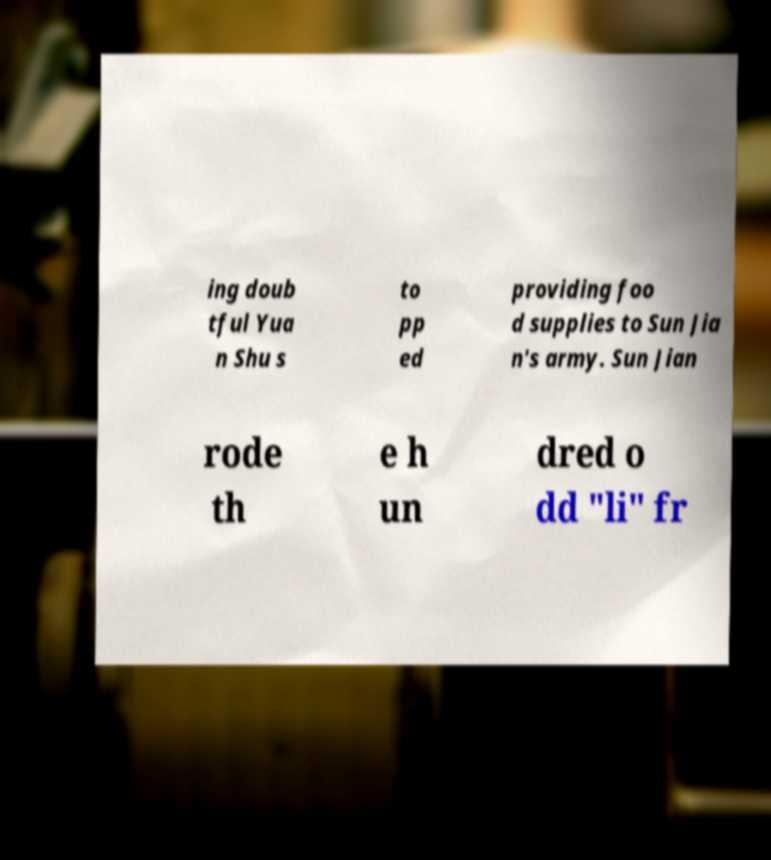I need the written content from this picture converted into text. Can you do that? ing doub tful Yua n Shu s to pp ed providing foo d supplies to Sun Jia n's army. Sun Jian rode th e h un dred o dd "li" fr 